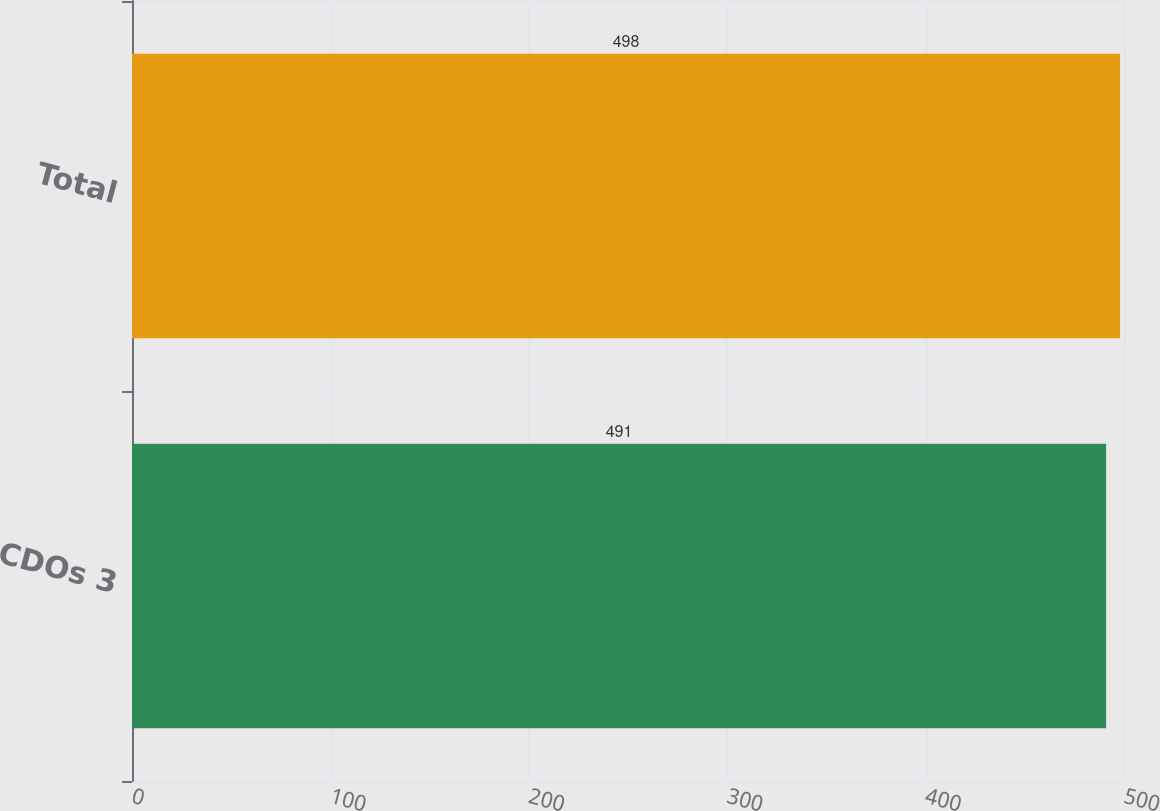Convert chart to OTSL. <chart><loc_0><loc_0><loc_500><loc_500><bar_chart><fcel>CDOs 3<fcel>Total<nl><fcel>491<fcel>498<nl></chart> 